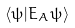Convert formula to latex. <formula><loc_0><loc_0><loc_500><loc_500>\langle \psi | E _ { A } \psi \rangle</formula> 